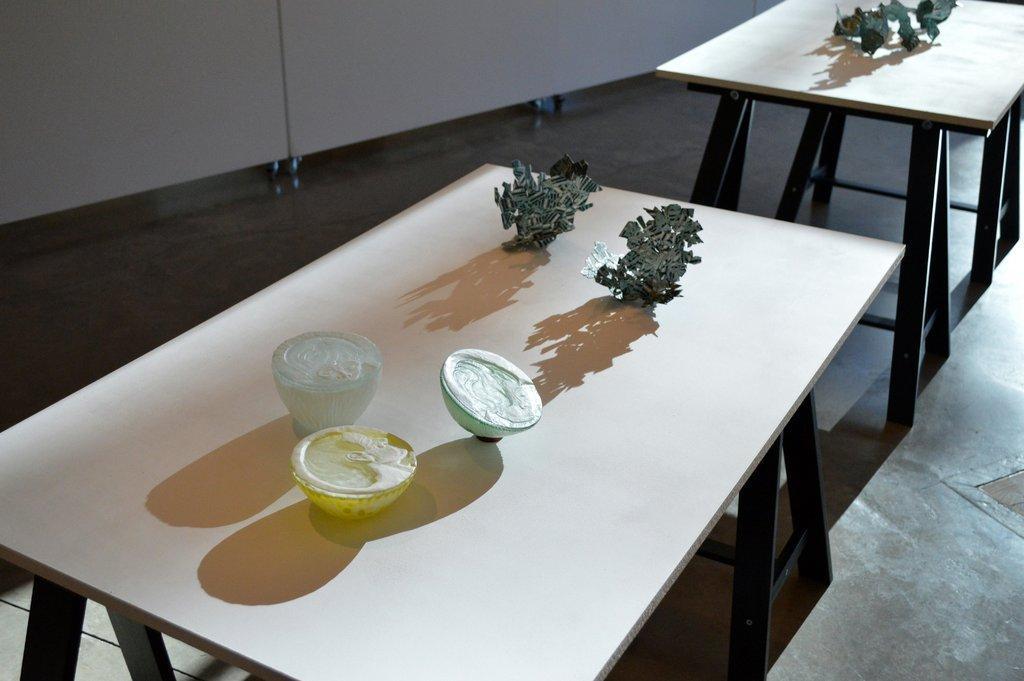In one or two sentences, can you explain what this image depicts? In this image I can see some objects on the tables. 